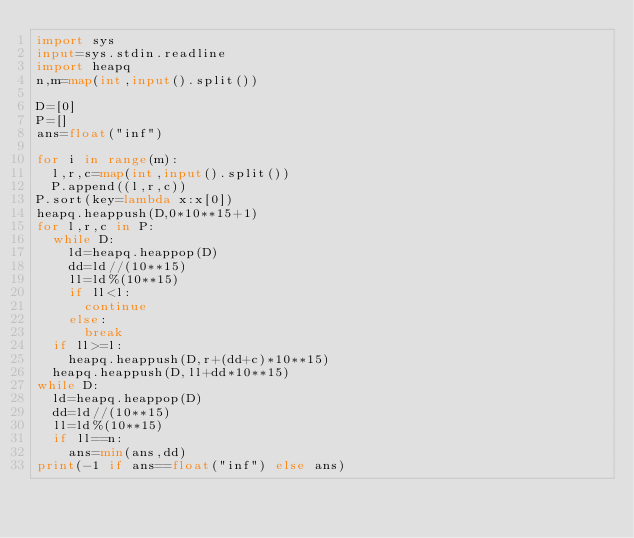<code> <loc_0><loc_0><loc_500><loc_500><_Python_>import sys
input=sys.stdin.readline
import heapq
n,m=map(int,input().split())

D=[0]
P=[]
ans=float("inf")

for i in range(m):
  l,r,c=map(int,input().split())
  P.append((l,r,c))
P.sort(key=lambda x:x[0])
heapq.heappush(D,0*10**15+1)
for l,r,c in P:
  while D:
    ld=heapq.heappop(D)
    dd=ld//(10**15)
    ll=ld%(10**15)
    if ll<l:
      continue
    else:
      break
  if ll>=l:
    heapq.heappush(D,r+(dd+c)*10**15)
  heapq.heappush(D,ll+dd*10**15)
while D:
  ld=heapq.heappop(D)
  dd=ld//(10**15)
  ll=ld%(10**15)
  if ll==n:
    ans=min(ans,dd)
print(-1 if ans==float("inf") else ans)


  </code> 